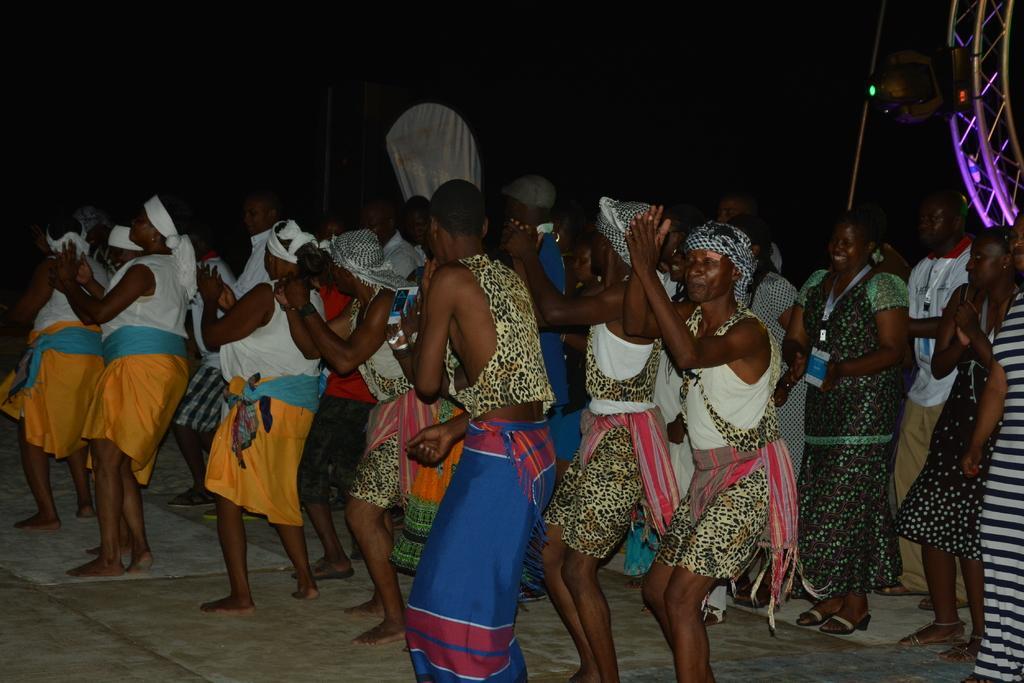Please provide a concise description of this image. In this picture, there are group of people dancing on the floor. Some of them are wearing white tops. Towards the right, there are two women and the background is dark. 